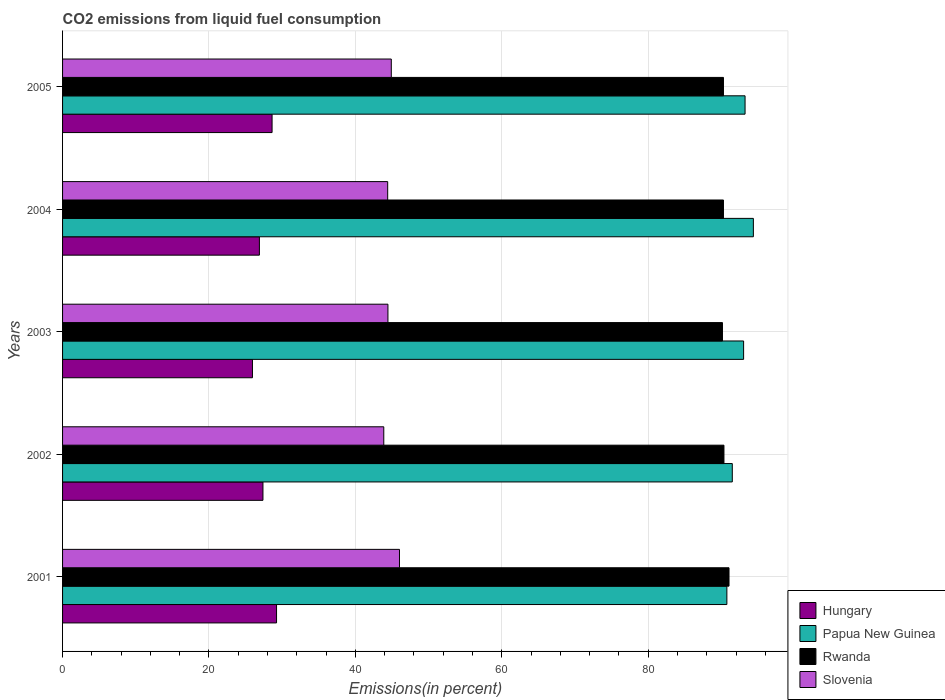How many different coloured bars are there?
Your answer should be compact. 4. How many groups of bars are there?
Make the answer very short. 5. How many bars are there on the 3rd tick from the top?
Your answer should be compact. 4. What is the label of the 5th group of bars from the top?
Offer a very short reply. 2001. In how many cases, is the number of bars for a given year not equal to the number of legend labels?
Provide a succinct answer. 0. What is the total CO2 emitted in Papua New Guinea in 2001?
Your answer should be compact. 90.74. Across all years, what is the maximum total CO2 emitted in Slovenia?
Provide a short and direct response. 46.02. Across all years, what is the minimum total CO2 emitted in Rwanda?
Provide a short and direct response. 90.14. What is the total total CO2 emitted in Hungary in the graph?
Ensure brevity in your answer.  138.05. What is the difference between the total CO2 emitted in Rwanda in 2001 and that in 2003?
Your answer should be compact. 0.89. What is the difference between the total CO2 emitted in Rwanda in 2004 and the total CO2 emitted in Slovenia in 2005?
Your answer should be very brief. 45.37. What is the average total CO2 emitted in Slovenia per year?
Provide a short and direct response. 44.73. In the year 2002, what is the difference between the total CO2 emitted in Hungary and total CO2 emitted in Rwanda?
Make the answer very short. -62.97. What is the ratio of the total CO2 emitted in Rwanda in 2001 to that in 2004?
Make the answer very short. 1.01. Is the total CO2 emitted in Hungary in 2001 less than that in 2003?
Keep it short and to the point. No. Is the difference between the total CO2 emitted in Hungary in 2001 and 2005 greater than the difference between the total CO2 emitted in Rwanda in 2001 and 2005?
Your response must be concise. No. What is the difference between the highest and the second highest total CO2 emitted in Slovenia?
Keep it short and to the point. 1.12. What is the difference between the highest and the lowest total CO2 emitted in Slovenia?
Keep it short and to the point. 2.15. Is the sum of the total CO2 emitted in Rwanda in 2001 and 2005 greater than the maximum total CO2 emitted in Slovenia across all years?
Make the answer very short. Yes. Is it the case that in every year, the sum of the total CO2 emitted in Hungary and total CO2 emitted in Papua New Guinea is greater than the sum of total CO2 emitted in Rwanda and total CO2 emitted in Slovenia?
Offer a terse response. No. What does the 4th bar from the top in 2004 represents?
Offer a very short reply. Hungary. What does the 2nd bar from the bottom in 2002 represents?
Give a very brief answer. Papua New Guinea. Is it the case that in every year, the sum of the total CO2 emitted in Slovenia and total CO2 emitted in Rwanda is greater than the total CO2 emitted in Hungary?
Make the answer very short. Yes. How many years are there in the graph?
Provide a succinct answer. 5. What is the difference between two consecutive major ticks on the X-axis?
Your answer should be very brief. 20. Are the values on the major ticks of X-axis written in scientific E-notation?
Keep it short and to the point. No. Does the graph contain any zero values?
Offer a very short reply. No. What is the title of the graph?
Keep it short and to the point. CO2 emissions from liquid fuel consumption. What is the label or title of the X-axis?
Your response must be concise. Emissions(in percent). What is the Emissions(in percent) in Hungary in 2001?
Offer a very short reply. 29.23. What is the Emissions(in percent) of Papua New Guinea in 2001?
Offer a very short reply. 90.74. What is the Emissions(in percent) of Rwanda in 2001?
Make the answer very short. 91.03. What is the Emissions(in percent) of Slovenia in 2001?
Offer a very short reply. 46.02. What is the Emissions(in percent) in Hungary in 2002?
Provide a short and direct response. 27.37. What is the Emissions(in percent) of Papua New Guinea in 2002?
Ensure brevity in your answer.  91.48. What is the Emissions(in percent) of Rwanda in 2002?
Ensure brevity in your answer.  90.34. What is the Emissions(in percent) in Slovenia in 2002?
Ensure brevity in your answer.  43.88. What is the Emissions(in percent) of Hungary in 2003?
Ensure brevity in your answer.  25.94. What is the Emissions(in percent) in Papua New Guinea in 2003?
Offer a very short reply. 93.03. What is the Emissions(in percent) in Rwanda in 2003?
Your answer should be very brief. 90.14. What is the Emissions(in percent) of Slovenia in 2003?
Your response must be concise. 44.44. What is the Emissions(in percent) in Hungary in 2004?
Your answer should be very brief. 26.89. What is the Emissions(in percent) in Papua New Guinea in 2004?
Keep it short and to the point. 94.36. What is the Emissions(in percent) in Rwanda in 2004?
Your answer should be compact. 90.28. What is the Emissions(in percent) of Slovenia in 2004?
Offer a terse response. 44.41. What is the Emissions(in percent) of Hungary in 2005?
Your answer should be compact. 28.62. What is the Emissions(in percent) of Papua New Guinea in 2005?
Your response must be concise. 93.23. What is the Emissions(in percent) of Rwanda in 2005?
Provide a short and direct response. 90.28. What is the Emissions(in percent) in Slovenia in 2005?
Make the answer very short. 44.9. Across all years, what is the maximum Emissions(in percent) of Hungary?
Provide a short and direct response. 29.23. Across all years, what is the maximum Emissions(in percent) in Papua New Guinea?
Provide a succinct answer. 94.36. Across all years, what is the maximum Emissions(in percent) of Rwanda?
Offer a terse response. 91.03. Across all years, what is the maximum Emissions(in percent) of Slovenia?
Your answer should be very brief. 46.02. Across all years, what is the minimum Emissions(in percent) of Hungary?
Give a very brief answer. 25.94. Across all years, what is the minimum Emissions(in percent) of Papua New Guinea?
Offer a terse response. 90.74. Across all years, what is the minimum Emissions(in percent) in Rwanda?
Your answer should be very brief. 90.14. Across all years, what is the minimum Emissions(in percent) in Slovenia?
Your answer should be very brief. 43.88. What is the total Emissions(in percent) in Hungary in the graph?
Provide a short and direct response. 138.05. What is the total Emissions(in percent) in Papua New Guinea in the graph?
Your response must be concise. 462.85. What is the total Emissions(in percent) of Rwanda in the graph?
Make the answer very short. 452.08. What is the total Emissions(in percent) of Slovenia in the graph?
Make the answer very short. 223.66. What is the difference between the Emissions(in percent) in Hungary in 2001 and that in 2002?
Your answer should be very brief. 1.86. What is the difference between the Emissions(in percent) in Papua New Guinea in 2001 and that in 2002?
Offer a very short reply. -0.74. What is the difference between the Emissions(in percent) of Rwanda in 2001 and that in 2002?
Offer a very short reply. 0.69. What is the difference between the Emissions(in percent) in Slovenia in 2001 and that in 2002?
Ensure brevity in your answer.  2.15. What is the difference between the Emissions(in percent) in Hungary in 2001 and that in 2003?
Provide a short and direct response. 3.29. What is the difference between the Emissions(in percent) of Papua New Guinea in 2001 and that in 2003?
Provide a short and direct response. -2.29. What is the difference between the Emissions(in percent) in Rwanda in 2001 and that in 2003?
Make the answer very short. 0.89. What is the difference between the Emissions(in percent) in Slovenia in 2001 and that in 2003?
Your answer should be compact. 1.58. What is the difference between the Emissions(in percent) of Hungary in 2001 and that in 2004?
Offer a terse response. 2.34. What is the difference between the Emissions(in percent) of Papua New Guinea in 2001 and that in 2004?
Provide a succinct answer. -3.62. What is the difference between the Emissions(in percent) in Rwanda in 2001 and that in 2004?
Your response must be concise. 0.76. What is the difference between the Emissions(in percent) of Slovenia in 2001 and that in 2004?
Keep it short and to the point. 1.61. What is the difference between the Emissions(in percent) of Hungary in 2001 and that in 2005?
Make the answer very short. 0.61. What is the difference between the Emissions(in percent) in Papua New Guinea in 2001 and that in 2005?
Your response must be concise. -2.48. What is the difference between the Emissions(in percent) in Rwanda in 2001 and that in 2005?
Offer a very short reply. 0.76. What is the difference between the Emissions(in percent) in Slovenia in 2001 and that in 2005?
Offer a terse response. 1.12. What is the difference between the Emissions(in percent) in Hungary in 2002 and that in 2003?
Your response must be concise. 1.43. What is the difference between the Emissions(in percent) of Papua New Guinea in 2002 and that in 2003?
Your answer should be compact. -1.55. What is the difference between the Emissions(in percent) in Rwanda in 2002 and that in 2003?
Your answer should be very brief. 0.2. What is the difference between the Emissions(in percent) in Slovenia in 2002 and that in 2003?
Your answer should be compact. -0.57. What is the difference between the Emissions(in percent) of Hungary in 2002 and that in 2004?
Make the answer very short. 0.48. What is the difference between the Emissions(in percent) of Papua New Guinea in 2002 and that in 2004?
Ensure brevity in your answer.  -2.88. What is the difference between the Emissions(in percent) of Rwanda in 2002 and that in 2004?
Offer a terse response. 0.07. What is the difference between the Emissions(in percent) of Slovenia in 2002 and that in 2004?
Give a very brief answer. -0.53. What is the difference between the Emissions(in percent) of Hungary in 2002 and that in 2005?
Your answer should be compact. -1.25. What is the difference between the Emissions(in percent) of Papua New Guinea in 2002 and that in 2005?
Offer a terse response. -1.74. What is the difference between the Emissions(in percent) of Rwanda in 2002 and that in 2005?
Provide a short and direct response. 0.07. What is the difference between the Emissions(in percent) of Slovenia in 2002 and that in 2005?
Your answer should be compact. -1.03. What is the difference between the Emissions(in percent) in Hungary in 2003 and that in 2004?
Provide a succinct answer. -0.95. What is the difference between the Emissions(in percent) of Papua New Guinea in 2003 and that in 2004?
Give a very brief answer. -1.33. What is the difference between the Emissions(in percent) in Rwanda in 2003 and that in 2004?
Offer a terse response. -0.14. What is the difference between the Emissions(in percent) of Slovenia in 2003 and that in 2004?
Make the answer very short. 0.03. What is the difference between the Emissions(in percent) in Hungary in 2003 and that in 2005?
Provide a succinct answer. -2.68. What is the difference between the Emissions(in percent) of Papua New Guinea in 2003 and that in 2005?
Offer a very short reply. -0.2. What is the difference between the Emissions(in percent) in Rwanda in 2003 and that in 2005?
Your answer should be very brief. -0.14. What is the difference between the Emissions(in percent) in Slovenia in 2003 and that in 2005?
Provide a short and direct response. -0.46. What is the difference between the Emissions(in percent) of Hungary in 2004 and that in 2005?
Provide a succinct answer. -1.73. What is the difference between the Emissions(in percent) in Papua New Guinea in 2004 and that in 2005?
Provide a short and direct response. 1.14. What is the difference between the Emissions(in percent) in Rwanda in 2004 and that in 2005?
Provide a short and direct response. 0. What is the difference between the Emissions(in percent) in Slovenia in 2004 and that in 2005?
Make the answer very short. -0.49. What is the difference between the Emissions(in percent) of Hungary in 2001 and the Emissions(in percent) of Papua New Guinea in 2002?
Offer a terse response. -62.25. What is the difference between the Emissions(in percent) in Hungary in 2001 and the Emissions(in percent) in Rwanda in 2002?
Your response must be concise. -61.11. What is the difference between the Emissions(in percent) of Hungary in 2001 and the Emissions(in percent) of Slovenia in 2002?
Offer a terse response. -14.65. What is the difference between the Emissions(in percent) in Papua New Guinea in 2001 and the Emissions(in percent) in Rwanda in 2002?
Offer a terse response. 0.4. What is the difference between the Emissions(in percent) in Papua New Guinea in 2001 and the Emissions(in percent) in Slovenia in 2002?
Keep it short and to the point. 46.87. What is the difference between the Emissions(in percent) in Rwanda in 2001 and the Emissions(in percent) in Slovenia in 2002?
Make the answer very short. 47.16. What is the difference between the Emissions(in percent) of Hungary in 2001 and the Emissions(in percent) of Papua New Guinea in 2003?
Provide a succinct answer. -63.8. What is the difference between the Emissions(in percent) in Hungary in 2001 and the Emissions(in percent) in Rwanda in 2003?
Make the answer very short. -60.91. What is the difference between the Emissions(in percent) of Hungary in 2001 and the Emissions(in percent) of Slovenia in 2003?
Offer a very short reply. -15.21. What is the difference between the Emissions(in percent) in Papua New Guinea in 2001 and the Emissions(in percent) in Rwanda in 2003?
Your response must be concise. 0.6. What is the difference between the Emissions(in percent) in Papua New Guinea in 2001 and the Emissions(in percent) in Slovenia in 2003?
Keep it short and to the point. 46.3. What is the difference between the Emissions(in percent) of Rwanda in 2001 and the Emissions(in percent) of Slovenia in 2003?
Offer a terse response. 46.59. What is the difference between the Emissions(in percent) in Hungary in 2001 and the Emissions(in percent) in Papua New Guinea in 2004?
Give a very brief answer. -65.13. What is the difference between the Emissions(in percent) in Hungary in 2001 and the Emissions(in percent) in Rwanda in 2004?
Give a very brief answer. -61.05. What is the difference between the Emissions(in percent) of Hungary in 2001 and the Emissions(in percent) of Slovenia in 2004?
Your answer should be compact. -15.18. What is the difference between the Emissions(in percent) in Papua New Guinea in 2001 and the Emissions(in percent) in Rwanda in 2004?
Offer a terse response. 0.47. What is the difference between the Emissions(in percent) of Papua New Guinea in 2001 and the Emissions(in percent) of Slovenia in 2004?
Keep it short and to the point. 46.33. What is the difference between the Emissions(in percent) in Rwanda in 2001 and the Emissions(in percent) in Slovenia in 2004?
Make the answer very short. 46.62. What is the difference between the Emissions(in percent) in Hungary in 2001 and the Emissions(in percent) in Papua New Guinea in 2005?
Ensure brevity in your answer.  -64. What is the difference between the Emissions(in percent) of Hungary in 2001 and the Emissions(in percent) of Rwanda in 2005?
Make the answer very short. -61.05. What is the difference between the Emissions(in percent) of Hungary in 2001 and the Emissions(in percent) of Slovenia in 2005?
Offer a very short reply. -15.67. What is the difference between the Emissions(in percent) in Papua New Guinea in 2001 and the Emissions(in percent) in Rwanda in 2005?
Provide a short and direct response. 0.47. What is the difference between the Emissions(in percent) of Papua New Guinea in 2001 and the Emissions(in percent) of Slovenia in 2005?
Ensure brevity in your answer.  45.84. What is the difference between the Emissions(in percent) in Rwanda in 2001 and the Emissions(in percent) in Slovenia in 2005?
Offer a terse response. 46.13. What is the difference between the Emissions(in percent) in Hungary in 2002 and the Emissions(in percent) in Papua New Guinea in 2003?
Provide a succinct answer. -65.66. What is the difference between the Emissions(in percent) of Hungary in 2002 and the Emissions(in percent) of Rwanda in 2003?
Offer a very short reply. -62.77. What is the difference between the Emissions(in percent) in Hungary in 2002 and the Emissions(in percent) in Slovenia in 2003?
Ensure brevity in your answer.  -17.07. What is the difference between the Emissions(in percent) of Papua New Guinea in 2002 and the Emissions(in percent) of Rwanda in 2003?
Keep it short and to the point. 1.34. What is the difference between the Emissions(in percent) of Papua New Guinea in 2002 and the Emissions(in percent) of Slovenia in 2003?
Offer a very short reply. 47.04. What is the difference between the Emissions(in percent) in Rwanda in 2002 and the Emissions(in percent) in Slovenia in 2003?
Ensure brevity in your answer.  45.9. What is the difference between the Emissions(in percent) of Hungary in 2002 and the Emissions(in percent) of Papua New Guinea in 2004?
Your response must be concise. -66.99. What is the difference between the Emissions(in percent) of Hungary in 2002 and the Emissions(in percent) of Rwanda in 2004?
Make the answer very short. -62.91. What is the difference between the Emissions(in percent) of Hungary in 2002 and the Emissions(in percent) of Slovenia in 2004?
Your answer should be very brief. -17.04. What is the difference between the Emissions(in percent) of Papua New Guinea in 2002 and the Emissions(in percent) of Rwanda in 2004?
Your response must be concise. 1.2. What is the difference between the Emissions(in percent) in Papua New Guinea in 2002 and the Emissions(in percent) in Slovenia in 2004?
Keep it short and to the point. 47.07. What is the difference between the Emissions(in percent) in Rwanda in 2002 and the Emissions(in percent) in Slovenia in 2004?
Provide a short and direct response. 45.93. What is the difference between the Emissions(in percent) in Hungary in 2002 and the Emissions(in percent) in Papua New Guinea in 2005?
Ensure brevity in your answer.  -65.86. What is the difference between the Emissions(in percent) of Hungary in 2002 and the Emissions(in percent) of Rwanda in 2005?
Provide a succinct answer. -62.91. What is the difference between the Emissions(in percent) of Hungary in 2002 and the Emissions(in percent) of Slovenia in 2005?
Offer a terse response. -17.53. What is the difference between the Emissions(in percent) of Papua New Guinea in 2002 and the Emissions(in percent) of Rwanda in 2005?
Give a very brief answer. 1.2. What is the difference between the Emissions(in percent) in Papua New Guinea in 2002 and the Emissions(in percent) in Slovenia in 2005?
Give a very brief answer. 46.58. What is the difference between the Emissions(in percent) in Rwanda in 2002 and the Emissions(in percent) in Slovenia in 2005?
Ensure brevity in your answer.  45.44. What is the difference between the Emissions(in percent) in Hungary in 2003 and the Emissions(in percent) in Papua New Guinea in 2004?
Provide a short and direct response. -68.42. What is the difference between the Emissions(in percent) in Hungary in 2003 and the Emissions(in percent) in Rwanda in 2004?
Provide a short and direct response. -64.34. What is the difference between the Emissions(in percent) of Hungary in 2003 and the Emissions(in percent) of Slovenia in 2004?
Ensure brevity in your answer.  -18.47. What is the difference between the Emissions(in percent) of Papua New Guinea in 2003 and the Emissions(in percent) of Rwanda in 2004?
Offer a very short reply. 2.75. What is the difference between the Emissions(in percent) of Papua New Guinea in 2003 and the Emissions(in percent) of Slovenia in 2004?
Your response must be concise. 48.62. What is the difference between the Emissions(in percent) of Rwanda in 2003 and the Emissions(in percent) of Slovenia in 2004?
Your response must be concise. 45.73. What is the difference between the Emissions(in percent) of Hungary in 2003 and the Emissions(in percent) of Papua New Guinea in 2005?
Your answer should be very brief. -67.29. What is the difference between the Emissions(in percent) in Hungary in 2003 and the Emissions(in percent) in Rwanda in 2005?
Your answer should be very brief. -64.34. What is the difference between the Emissions(in percent) of Hungary in 2003 and the Emissions(in percent) of Slovenia in 2005?
Give a very brief answer. -18.97. What is the difference between the Emissions(in percent) of Papua New Guinea in 2003 and the Emissions(in percent) of Rwanda in 2005?
Ensure brevity in your answer.  2.75. What is the difference between the Emissions(in percent) in Papua New Guinea in 2003 and the Emissions(in percent) in Slovenia in 2005?
Provide a short and direct response. 48.13. What is the difference between the Emissions(in percent) of Rwanda in 2003 and the Emissions(in percent) of Slovenia in 2005?
Keep it short and to the point. 45.24. What is the difference between the Emissions(in percent) of Hungary in 2004 and the Emissions(in percent) of Papua New Guinea in 2005?
Make the answer very short. -66.34. What is the difference between the Emissions(in percent) of Hungary in 2004 and the Emissions(in percent) of Rwanda in 2005?
Your answer should be very brief. -63.39. What is the difference between the Emissions(in percent) in Hungary in 2004 and the Emissions(in percent) in Slovenia in 2005?
Provide a succinct answer. -18.02. What is the difference between the Emissions(in percent) of Papua New Guinea in 2004 and the Emissions(in percent) of Rwanda in 2005?
Give a very brief answer. 4.08. What is the difference between the Emissions(in percent) of Papua New Guinea in 2004 and the Emissions(in percent) of Slovenia in 2005?
Your answer should be very brief. 49.46. What is the difference between the Emissions(in percent) in Rwanda in 2004 and the Emissions(in percent) in Slovenia in 2005?
Your response must be concise. 45.37. What is the average Emissions(in percent) in Hungary per year?
Make the answer very short. 27.61. What is the average Emissions(in percent) in Papua New Guinea per year?
Offer a very short reply. 92.57. What is the average Emissions(in percent) in Rwanda per year?
Keep it short and to the point. 90.42. What is the average Emissions(in percent) in Slovenia per year?
Your answer should be compact. 44.73. In the year 2001, what is the difference between the Emissions(in percent) of Hungary and Emissions(in percent) of Papua New Guinea?
Offer a very short reply. -61.51. In the year 2001, what is the difference between the Emissions(in percent) in Hungary and Emissions(in percent) in Rwanda?
Your answer should be very brief. -61.8. In the year 2001, what is the difference between the Emissions(in percent) of Hungary and Emissions(in percent) of Slovenia?
Give a very brief answer. -16.79. In the year 2001, what is the difference between the Emissions(in percent) in Papua New Guinea and Emissions(in percent) in Rwanda?
Your answer should be compact. -0.29. In the year 2001, what is the difference between the Emissions(in percent) of Papua New Guinea and Emissions(in percent) of Slovenia?
Offer a very short reply. 44.72. In the year 2001, what is the difference between the Emissions(in percent) in Rwanda and Emissions(in percent) in Slovenia?
Keep it short and to the point. 45.01. In the year 2002, what is the difference between the Emissions(in percent) of Hungary and Emissions(in percent) of Papua New Guinea?
Give a very brief answer. -64.11. In the year 2002, what is the difference between the Emissions(in percent) in Hungary and Emissions(in percent) in Rwanda?
Offer a very short reply. -62.97. In the year 2002, what is the difference between the Emissions(in percent) in Hungary and Emissions(in percent) in Slovenia?
Ensure brevity in your answer.  -16.5. In the year 2002, what is the difference between the Emissions(in percent) in Papua New Guinea and Emissions(in percent) in Rwanda?
Give a very brief answer. 1.14. In the year 2002, what is the difference between the Emissions(in percent) in Papua New Guinea and Emissions(in percent) in Slovenia?
Provide a succinct answer. 47.61. In the year 2002, what is the difference between the Emissions(in percent) in Rwanda and Emissions(in percent) in Slovenia?
Your answer should be compact. 46.47. In the year 2003, what is the difference between the Emissions(in percent) in Hungary and Emissions(in percent) in Papua New Guinea?
Provide a succinct answer. -67.09. In the year 2003, what is the difference between the Emissions(in percent) in Hungary and Emissions(in percent) in Rwanda?
Offer a terse response. -64.2. In the year 2003, what is the difference between the Emissions(in percent) in Hungary and Emissions(in percent) in Slovenia?
Give a very brief answer. -18.51. In the year 2003, what is the difference between the Emissions(in percent) of Papua New Guinea and Emissions(in percent) of Rwanda?
Ensure brevity in your answer.  2.89. In the year 2003, what is the difference between the Emissions(in percent) of Papua New Guinea and Emissions(in percent) of Slovenia?
Your response must be concise. 48.59. In the year 2003, what is the difference between the Emissions(in percent) of Rwanda and Emissions(in percent) of Slovenia?
Keep it short and to the point. 45.7. In the year 2004, what is the difference between the Emissions(in percent) of Hungary and Emissions(in percent) of Papua New Guinea?
Your answer should be compact. -67.48. In the year 2004, what is the difference between the Emissions(in percent) in Hungary and Emissions(in percent) in Rwanda?
Give a very brief answer. -63.39. In the year 2004, what is the difference between the Emissions(in percent) of Hungary and Emissions(in percent) of Slovenia?
Provide a short and direct response. -17.52. In the year 2004, what is the difference between the Emissions(in percent) of Papua New Guinea and Emissions(in percent) of Rwanda?
Keep it short and to the point. 4.08. In the year 2004, what is the difference between the Emissions(in percent) of Papua New Guinea and Emissions(in percent) of Slovenia?
Your answer should be compact. 49.95. In the year 2004, what is the difference between the Emissions(in percent) in Rwanda and Emissions(in percent) in Slovenia?
Provide a succinct answer. 45.87. In the year 2005, what is the difference between the Emissions(in percent) of Hungary and Emissions(in percent) of Papua New Guinea?
Offer a terse response. -64.61. In the year 2005, what is the difference between the Emissions(in percent) in Hungary and Emissions(in percent) in Rwanda?
Offer a terse response. -61.66. In the year 2005, what is the difference between the Emissions(in percent) in Hungary and Emissions(in percent) in Slovenia?
Offer a terse response. -16.29. In the year 2005, what is the difference between the Emissions(in percent) of Papua New Guinea and Emissions(in percent) of Rwanda?
Ensure brevity in your answer.  2.95. In the year 2005, what is the difference between the Emissions(in percent) in Papua New Guinea and Emissions(in percent) in Slovenia?
Give a very brief answer. 48.32. In the year 2005, what is the difference between the Emissions(in percent) of Rwanda and Emissions(in percent) of Slovenia?
Make the answer very short. 45.37. What is the ratio of the Emissions(in percent) of Hungary in 2001 to that in 2002?
Offer a very short reply. 1.07. What is the ratio of the Emissions(in percent) in Rwanda in 2001 to that in 2002?
Ensure brevity in your answer.  1.01. What is the ratio of the Emissions(in percent) in Slovenia in 2001 to that in 2002?
Offer a very short reply. 1.05. What is the ratio of the Emissions(in percent) in Hungary in 2001 to that in 2003?
Provide a succinct answer. 1.13. What is the ratio of the Emissions(in percent) of Papua New Guinea in 2001 to that in 2003?
Provide a succinct answer. 0.98. What is the ratio of the Emissions(in percent) in Rwanda in 2001 to that in 2003?
Your answer should be very brief. 1.01. What is the ratio of the Emissions(in percent) in Slovenia in 2001 to that in 2003?
Provide a succinct answer. 1.04. What is the ratio of the Emissions(in percent) of Hungary in 2001 to that in 2004?
Offer a very short reply. 1.09. What is the ratio of the Emissions(in percent) in Papua New Guinea in 2001 to that in 2004?
Give a very brief answer. 0.96. What is the ratio of the Emissions(in percent) of Rwanda in 2001 to that in 2004?
Offer a very short reply. 1.01. What is the ratio of the Emissions(in percent) of Slovenia in 2001 to that in 2004?
Ensure brevity in your answer.  1.04. What is the ratio of the Emissions(in percent) in Hungary in 2001 to that in 2005?
Your answer should be very brief. 1.02. What is the ratio of the Emissions(in percent) of Papua New Guinea in 2001 to that in 2005?
Provide a succinct answer. 0.97. What is the ratio of the Emissions(in percent) in Rwanda in 2001 to that in 2005?
Your response must be concise. 1.01. What is the ratio of the Emissions(in percent) of Slovenia in 2001 to that in 2005?
Provide a short and direct response. 1.02. What is the ratio of the Emissions(in percent) in Hungary in 2002 to that in 2003?
Keep it short and to the point. 1.06. What is the ratio of the Emissions(in percent) of Papua New Guinea in 2002 to that in 2003?
Make the answer very short. 0.98. What is the ratio of the Emissions(in percent) in Slovenia in 2002 to that in 2003?
Ensure brevity in your answer.  0.99. What is the ratio of the Emissions(in percent) in Papua New Guinea in 2002 to that in 2004?
Provide a succinct answer. 0.97. What is the ratio of the Emissions(in percent) of Hungary in 2002 to that in 2005?
Offer a very short reply. 0.96. What is the ratio of the Emissions(in percent) in Papua New Guinea in 2002 to that in 2005?
Provide a short and direct response. 0.98. What is the ratio of the Emissions(in percent) in Rwanda in 2002 to that in 2005?
Your answer should be compact. 1. What is the ratio of the Emissions(in percent) in Slovenia in 2002 to that in 2005?
Your answer should be compact. 0.98. What is the ratio of the Emissions(in percent) in Hungary in 2003 to that in 2004?
Provide a short and direct response. 0.96. What is the ratio of the Emissions(in percent) of Papua New Guinea in 2003 to that in 2004?
Provide a succinct answer. 0.99. What is the ratio of the Emissions(in percent) of Rwanda in 2003 to that in 2004?
Your answer should be compact. 1. What is the ratio of the Emissions(in percent) in Slovenia in 2003 to that in 2004?
Keep it short and to the point. 1. What is the ratio of the Emissions(in percent) in Hungary in 2003 to that in 2005?
Offer a terse response. 0.91. What is the ratio of the Emissions(in percent) in Rwanda in 2003 to that in 2005?
Ensure brevity in your answer.  1. What is the ratio of the Emissions(in percent) of Slovenia in 2003 to that in 2005?
Offer a very short reply. 0.99. What is the ratio of the Emissions(in percent) in Hungary in 2004 to that in 2005?
Give a very brief answer. 0.94. What is the ratio of the Emissions(in percent) in Papua New Guinea in 2004 to that in 2005?
Your answer should be compact. 1.01. What is the difference between the highest and the second highest Emissions(in percent) in Hungary?
Offer a very short reply. 0.61. What is the difference between the highest and the second highest Emissions(in percent) of Papua New Guinea?
Make the answer very short. 1.14. What is the difference between the highest and the second highest Emissions(in percent) of Rwanda?
Keep it short and to the point. 0.69. What is the difference between the highest and the second highest Emissions(in percent) of Slovenia?
Offer a very short reply. 1.12. What is the difference between the highest and the lowest Emissions(in percent) of Hungary?
Provide a succinct answer. 3.29. What is the difference between the highest and the lowest Emissions(in percent) of Papua New Guinea?
Your answer should be very brief. 3.62. What is the difference between the highest and the lowest Emissions(in percent) of Rwanda?
Make the answer very short. 0.89. What is the difference between the highest and the lowest Emissions(in percent) in Slovenia?
Ensure brevity in your answer.  2.15. 